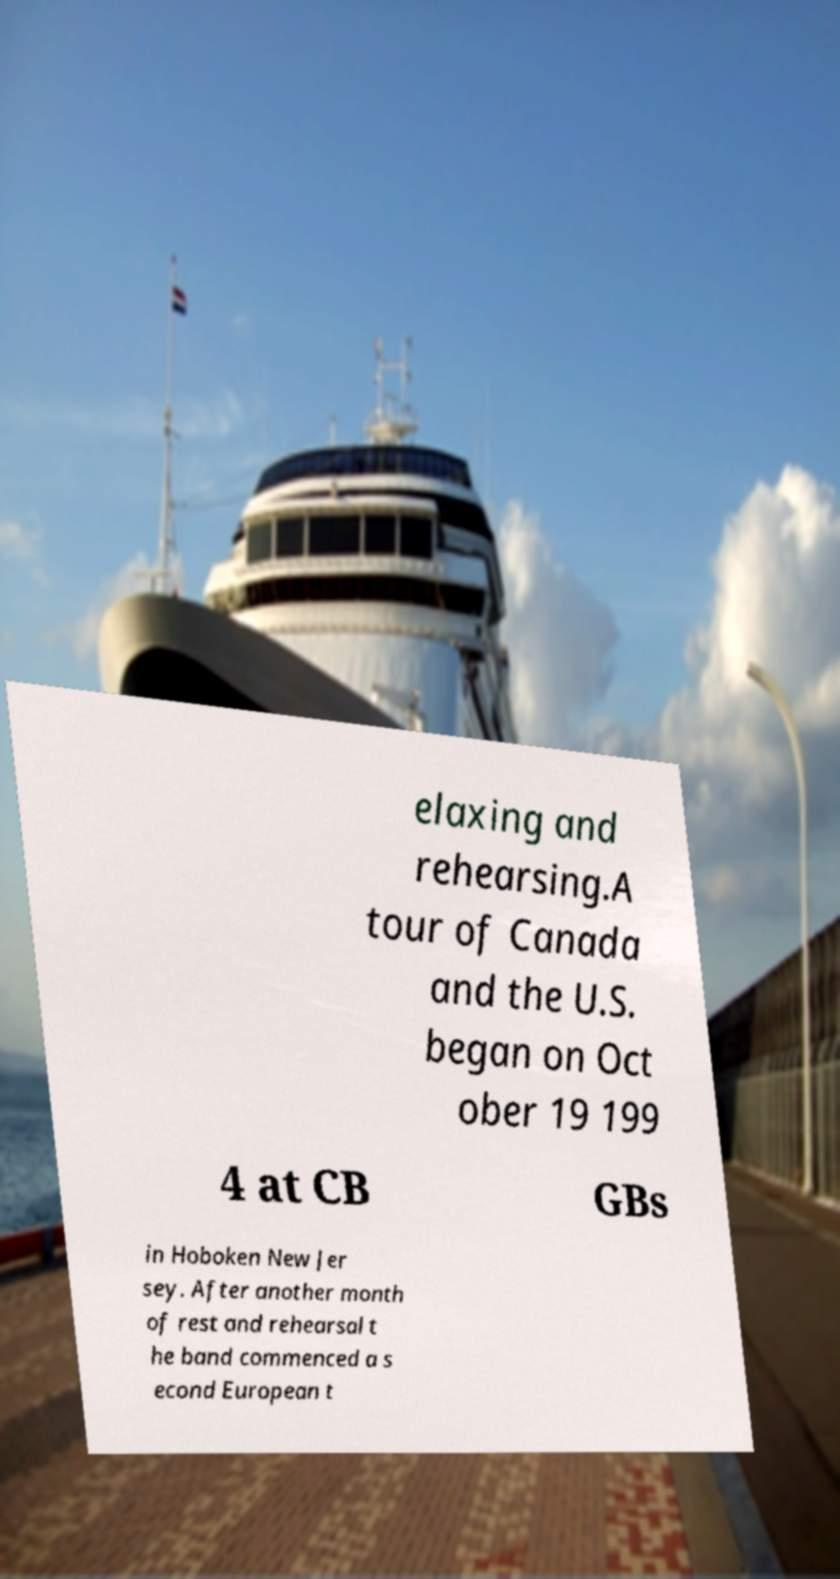Please read and relay the text visible in this image. What does it say? elaxing and rehearsing.A tour of Canada and the U.S. began on Oct ober 19 199 4 at CB GBs in Hoboken New Jer sey. After another month of rest and rehearsal t he band commenced a s econd European t 